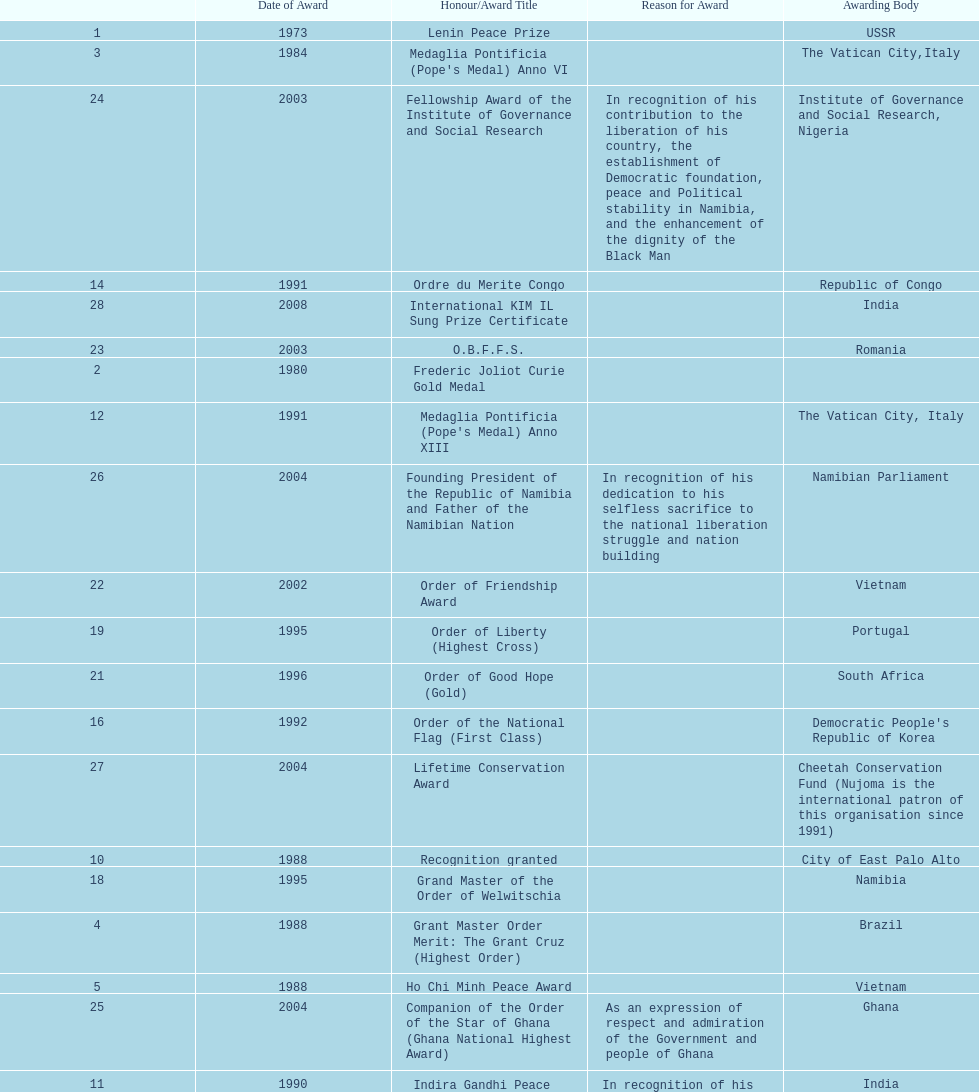Could you parse the entire table? {'header': ['', 'Date of Award', 'Honour/Award Title', 'Reason for Award', 'Awarding Body'], 'rows': [['1', '1973', 'Lenin Peace Prize', '', 'USSR'], ['3', '1984', "Medaglia Pontificia (Pope's Medal) Anno VI", '', 'The Vatican City,Italy'], ['24', '2003', 'Fellowship Award of the Institute of Governance and Social Research', 'In recognition of his contribution to the liberation of his country, the establishment of Democratic foundation, peace and Political stability in Namibia, and the enhancement of the dignity of the Black Man', 'Institute of Governance and Social Research, Nigeria'], ['14', '1991', 'Ordre du Merite Congo', '', 'Republic of Congo'], ['28', '2008', 'International KIM IL Sung Prize Certificate', '', 'India'], ['23', '2003', 'O.B.F.F.S.', '', 'Romania'], ['2', '1980', 'Frederic Joliot Curie Gold Medal', '', ''], ['12', '1991', "Medaglia Pontificia (Pope's Medal) Anno XIII", '', 'The Vatican City, Italy'], ['26', '2004', 'Founding President of the Republic of Namibia and Father of the Namibian Nation', 'In recognition of his dedication to his selfless sacrifice to the national liberation struggle and nation building', 'Namibian Parliament'], ['22', '2002', 'Order of Friendship Award', '', 'Vietnam'], ['19', '1995', 'Order of Liberty (Highest Cross)', '', 'Portugal'], ['21', '1996', 'Order of Good Hope (Gold)', '', 'South Africa'], ['16', '1992', 'Order of the National Flag (First Class)', '', "Democratic People's Republic of Korea"], ['27', '2004', 'Lifetime Conservation Award', '', 'Cheetah Conservation Fund (Nujoma is the international patron of this organisation since 1991)'], ['10', '1988', 'Recognition granted', '', 'City of East Palo Alto'], ['18', '1995', 'Grand Master of the Order of Welwitschia', '', 'Namibia'], ['4', '1988', 'Grant Master Order Merit: The Grant Cruz (Highest Order)', '', 'Brazil'], ['5', '1988', 'Ho Chi Minh Peace Award', '', 'Vietnam'], ['25', '2004', 'Companion of the Order of the Star of Ghana (Ghana National Highest Award)', 'As an expression of respect and admiration of the Government and people of Ghana', 'Ghana'], ['11', '1990', 'Indira Gandhi Peace Prize for Disarmament and Development', 'In recognition of his outstanding contribution in leading the people of Namibia to freedom', 'India'], ['13', '1991', 'Order of José Marti', '', 'Cuba'], ['20', '1995', 'Africa Prize for Leadership for the Sustainable End of Hunger', '', 'The Hunger Project'], ['9', '1988', 'Recognition granted', '', 'City of Chicago'], ['8', '1988', 'Recognition granted', '', 'City and County of San Francisco'], ['7', '1988', 'Honorary Citizenship of the City of Atlanta', 'For his leadership role in the struggle for freedom, national independence and social justice', 'Atlanta, USA'], ['17', '1994', '"Grand Cordon" Decoration', '', 'Tunisia'], ['29', '2010', 'Sir Seretse Khama SADC Meda', '', 'SADC'], ['15', '1992', 'Chief of Golden Heart', '', 'Kenya'], ['6', '1988', 'The Namibia Freedom Award', 'For his leadership role in the struggle against apartheid', 'California State University, USA']]} Did nujoma win the o.b.f.f.s. award in romania or ghana? Romania. 